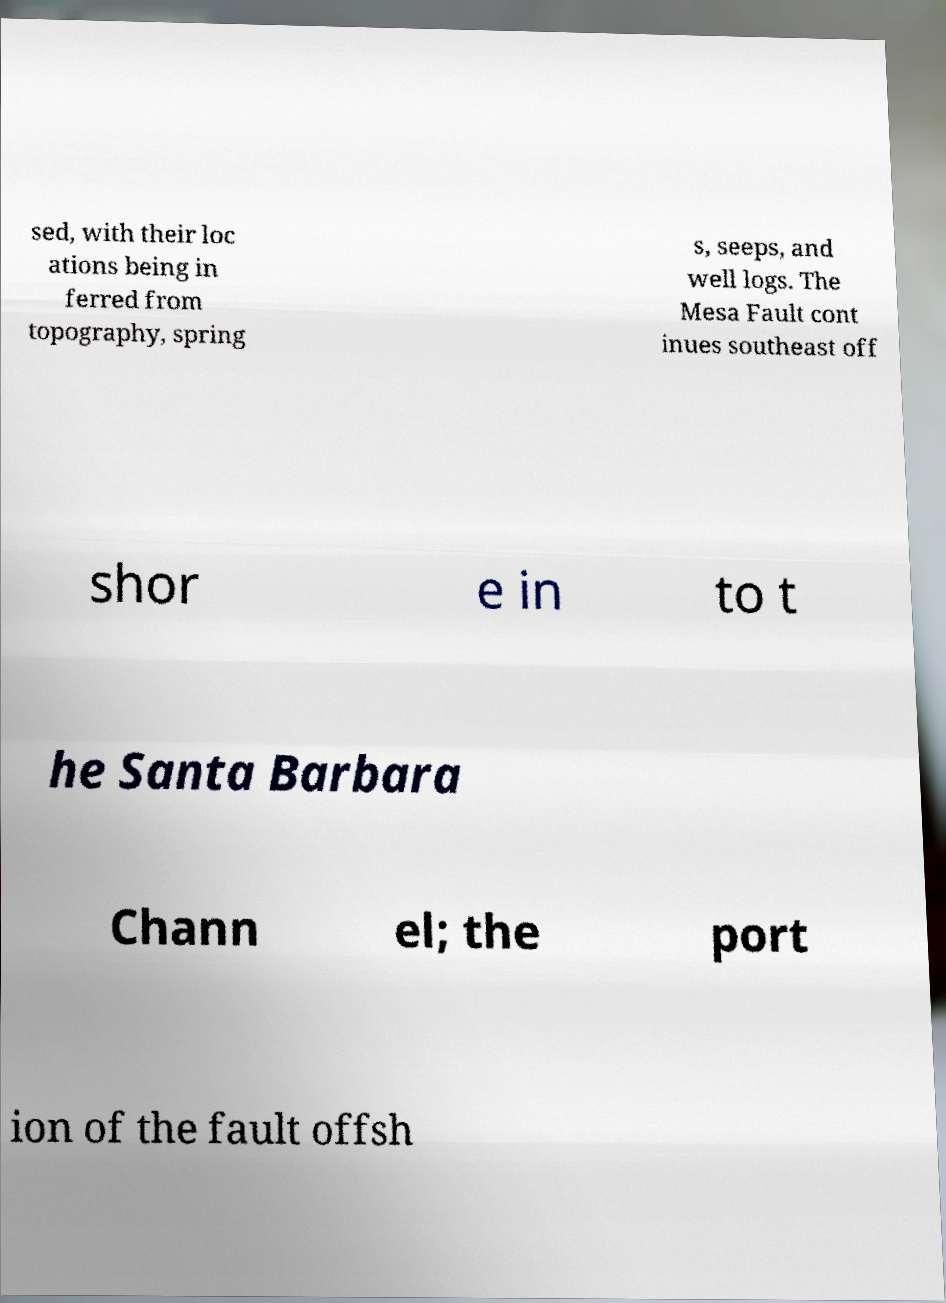I need the written content from this picture converted into text. Can you do that? sed, with their loc ations being in ferred from topography, spring s, seeps, and well logs. The Mesa Fault cont inues southeast off shor e in to t he Santa Barbara Chann el; the port ion of the fault offsh 